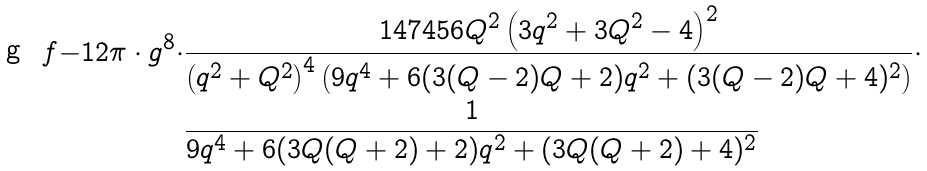Convert formula to latex. <formula><loc_0><loc_0><loc_500><loc_500>\ f { - 1 } { 2 \pi } \cdot g ^ { 8 } \cdot & \frac { 1 4 7 4 5 6 Q ^ { 2 } \left ( 3 q ^ { 2 } + 3 Q ^ { 2 } - 4 \right ) ^ { 2 } } { \left ( q ^ { 2 } + Q ^ { 2 } \right ) ^ { 4 } \left ( 9 q ^ { 4 } + 6 ( 3 ( Q - 2 ) Q + 2 ) q ^ { 2 } + ( 3 ( Q - 2 ) Q + 4 ) ^ { 2 } \right ) } \cdot \\ & \frac { 1 } { 9 q ^ { 4 } + 6 ( 3 Q ( Q + 2 ) + 2 ) q ^ { 2 } + ( 3 Q ( Q + 2 ) + 4 ) ^ { 2 } }</formula> 